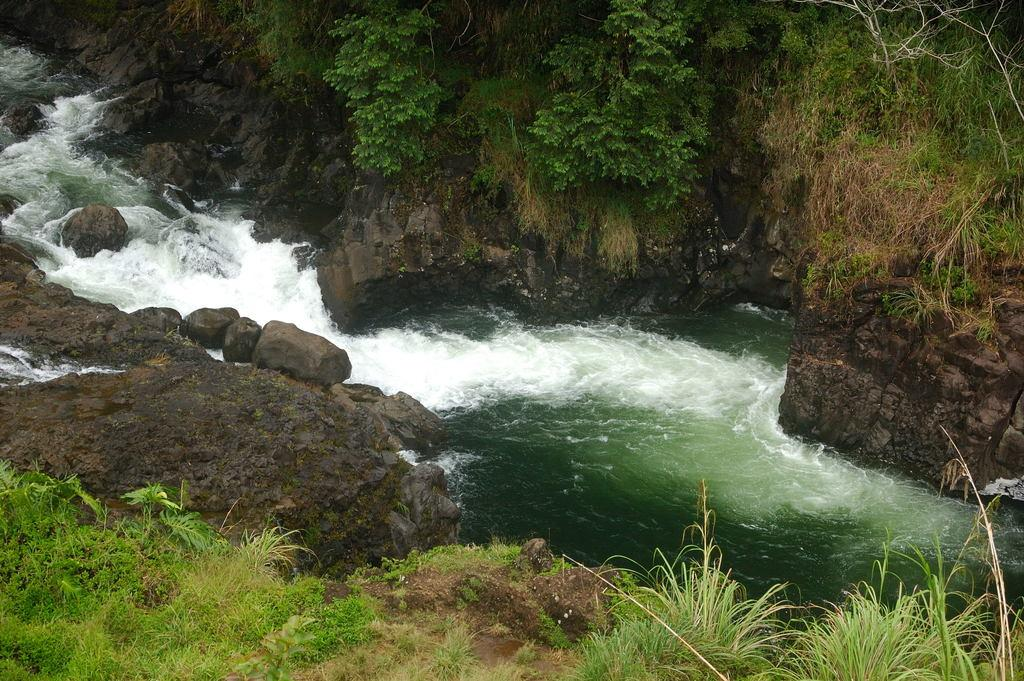What is the primary element visible in the image? There is water in the image. What type of vegetation can be seen on both sides of the water? There is grass and plants on both sides of the water. What other objects are present on both sides of the water? There are rocks on both sides of the water. Reasoning: Let's think step by step by step in order to produce the conversation. We start by identifying the main element in the image, which is the water. Then, we describe the surrounding environment, noting the presence of grass, plants, and rocks on both sides of the water. Each question is designed to elicit a specific detail about the image that is known from the provided facts. Absurd Question/Answer: How many pizzas are floating in the water in the image? There are no pizzas present in the image; it features water with grass, plants, and rocks on both sides. What shape is the circle that surrounds the water in the image? There is no circle surrounding the water in the image; it is not mentioned in the provided facts. 